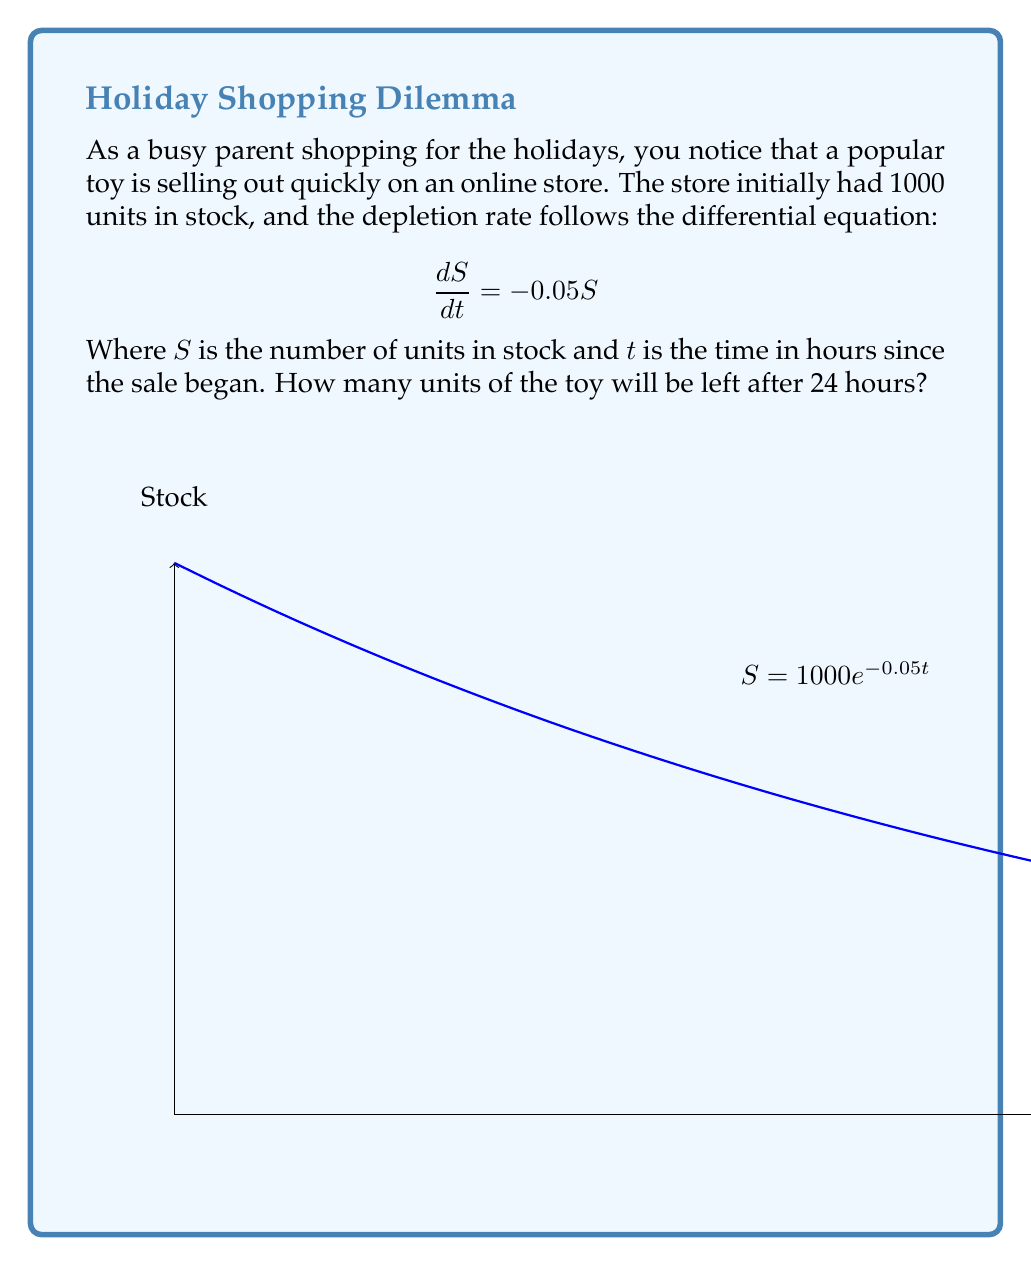Could you help me with this problem? To solve this problem, we need to follow these steps:

1) The given differential equation is:
   $$\frac{dS}{dt} = -0.05S$$

2) This is a separable differential equation. We can solve it as follows:
   $$\frac{dS}{S} = -0.05dt$$

3) Integrating both sides:
   $$\int \frac{dS}{S} = \int -0.05dt$$
   $$\ln|S| = -0.05t + C$$

4) We know that initially (t = 0), S = 1000. Using this initial condition:
   $$\ln(1000) = C$$
   $$C = \ln(1000)$$

5) Substituting back and simplifying:
   $$\ln|S| = -0.05t + \ln(1000)$$
   $$S = 1000e^{-0.05t}$$

6) Now, we want to find S when t = 24:
   $$S = 1000e^{-0.05(24)}$$
   $$S = 1000e^{-1.2}$$
   $$S \approx 301.19$$

7) Rounding to the nearest whole number (as we can't have fractional toys):
   $$S \approx 301$$
Answer: 301 units 